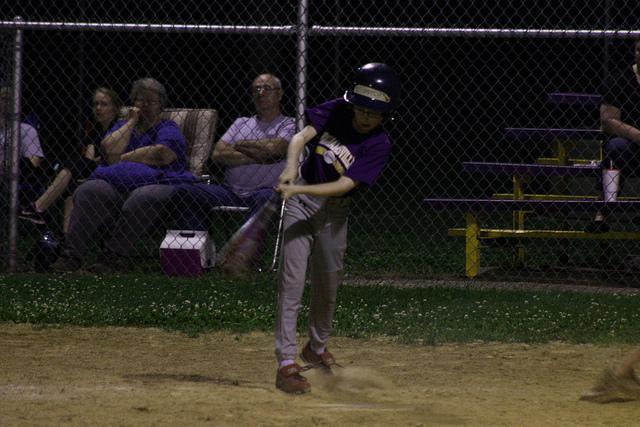How many people are on the playing field?
Give a very brief answer. 1. How many bats do you see?
Give a very brief answer. 1. How many benches are visible?
Give a very brief answer. 2. How many people can be seen?
Give a very brief answer. 6. 